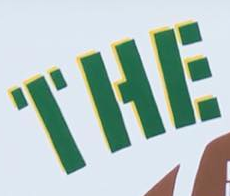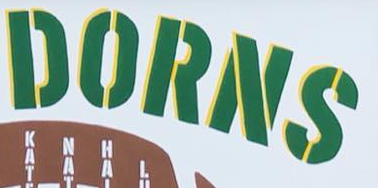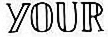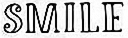What words can you see in these images in sequence, separated by a semicolon? THE; DORNS; YOUR; SMILE 